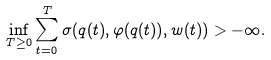Convert formula to latex. <formula><loc_0><loc_0><loc_500><loc_500>\inf _ { T \geq 0 } \sum _ { t = 0 } ^ { T } \sigma ( q ( t ) , \varphi ( q ( t ) ) , w ( t ) ) > - \infty .</formula> 